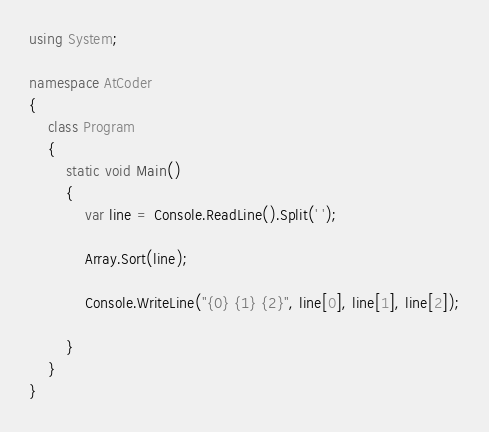Convert code to text. <code><loc_0><loc_0><loc_500><loc_500><_C#_>using System;

namespace AtCoder
{
    class Program
    {
        static void Main()
        {
            var line = Console.ReadLine().Split(' ');

            Array.Sort(line);

            Console.WriteLine("{0} {1} {2}", line[0], line[1], line[2]);
            
        }
    }
}

</code> 